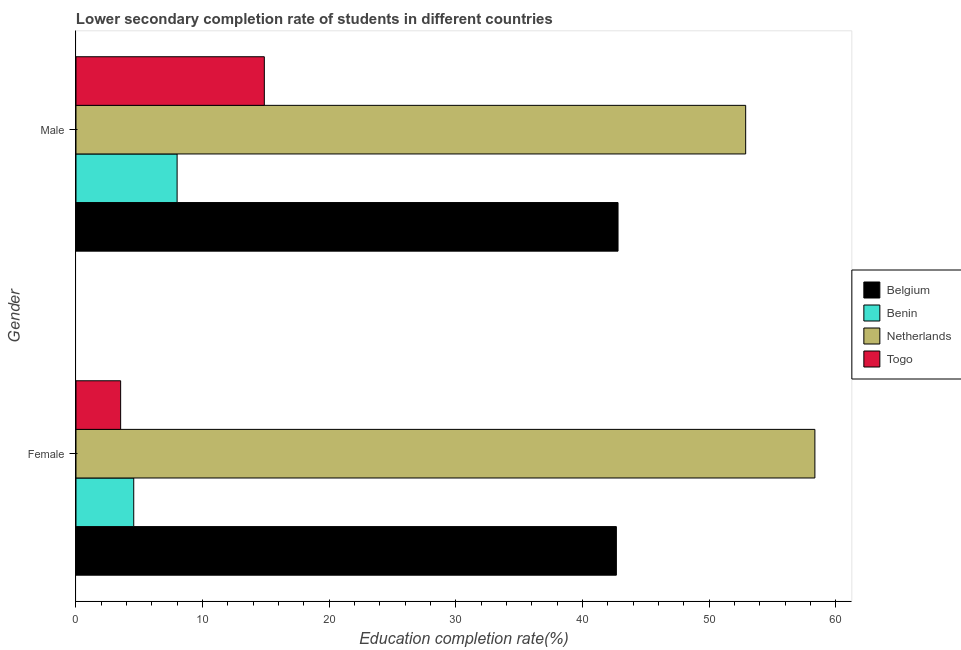How many bars are there on the 2nd tick from the bottom?
Ensure brevity in your answer.  4. What is the education completion rate of female students in Netherlands?
Make the answer very short. 58.34. Across all countries, what is the maximum education completion rate of male students?
Ensure brevity in your answer.  52.88. Across all countries, what is the minimum education completion rate of female students?
Provide a succinct answer. 3.53. In which country was the education completion rate of male students minimum?
Offer a very short reply. Benin. What is the total education completion rate of male students in the graph?
Your answer should be very brief. 118.54. What is the difference between the education completion rate of female students in Togo and that in Netherlands?
Offer a terse response. -54.82. What is the difference between the education completion rate of male students in Togo and the education completion rate of female students in Benin?
Offer a very short reply. 10.31. What is the average education completion rate of female students per country?
Make the answer very short. 27.27. What is the difference between the education completion rate of male students and education completion rate of female students in Togo?
Your response must be concise. 11.35. What is the ratio of the education completion rate of male students in Benin to that in Netherlands?
Your response must be concise. 0.15. Is the education completion rate of female students in Belgium less than that in Benin?
Ensure brevity in your answer.  No. In how many countries, is the education completion rate of male students greater than the average education completion rate of male students taken over all countries?
Offer a very short reply. 2. What does the 4th bar from the bottom in Male represents?
Offer a terse response. Togo. How many bars are there?
Your response must be concise. 8. How many countries are there in the graph?
Provide a short and direct response. 4. What is the difference between two consecutive major ticks on the X-axis?
Ensure brevity in your answer.  10. Does the graph contain grids?
Provide a short and direct response. No. How many legend labels are there?
Offer a very short reply. 4. How are the legend labels stacked?
Make the answer very short. Vertical. What is the title of the graph?
Your answer should be compact. Lower secondary completion rate of students in different countries. What is the label or title of the X-axis?
Your response must be concise. Education completion rate(%). What is the Education completion rate(%) of Belgium in Female?
Make the answer very short. 42.67. What is the Education completion rate(%) of Benin in Female?
Offer a very short reply. 4.56. What is the Education completion rate(%) in Netherlands in Female?
Make the answer very short. 58.34. What is the Education completion rate(%) in Togo in Female?
Your answer should be compact. 3.53. What is the Education completion rate(%) in Belgium in Male?
Give a very brief answer. 42.8. What is the Education completion rate(%) in Benin in Male?
Your answer should be compact. 7.98. What is the Education completion rate(%) of Netherlands in Male?
Your response must be concise. 52.88. What is the Education completion rate(%) in Togo in Male?
Your response must be concise. 14.87. Across all Gender, what is the maximum Education completion rate(%) in Belgium?
Your answer should be compact. 42.8. Across all Gender, what is the maximum Education completion rate(%) in Benin?
Give a very brief answer. 7.98. Across all Gender, what is the maximum Education completion rate(%) in Netherlands?
Give a very brief answer. 58.34. Across all Gender, what is the maximum Education completion rate(%) in Togo?
Make the answer very short. 14.87. Across all Gender, what is the minimum Education completion rate(%) of Belgium?
Offer a terse response. 42.67. Across all Gender, what is the minimum Education completion rate(%) of Benin?
Your answer should be very brief. 4.56. Across all Gender, what is the minimum Education completion rate(%) of Netherlands?
Your answer should be compact. 52.88. Across all Gender, what is the minimum Education completion rate(%) in Togo?
Give a very brief answer. 3.53. What is the total Education completion rate(%) in Belgium in the graph?
Give a very brief answer. 85.47. What is the total Education completion rate(%) in Benin in the graph?
Ensure brevity in your answer.  12.54. What is the total Education completion rate(%) in Netherlands in the graph?
Your answer should be very brief. 111.22. What is the total Education completion rate(%) in Togo in the graph?
Your answer should be compact. 18.4. What is the difference between the Education completion rate(%) in Belgium in Female and that in Male?
Give a very brief answer. -0.13. What is the difference between the Education completion rate(%) of Benin in Female and that in Male?
Make the answer very short. -3.42. What is the difference between the Education completion rate(%) in Netherlands in Female and that in Male?
Keep it short and to the point. 5.47. What is the difference between the Education completion rate(%) in Togo in Female and that in Male?
Your answer should be compact. -11.35. What is the difference between the Education completion rate(%) of Belgium in Female and the Education completion rate(%) of Benin in Male?
Make the answer very short. 34.69. What is the difference between the Education completion rate(%) in Belgium in Female and the Education completion rate(%) in Netherlands in Male?
Ensure brevity in your answer.  -10.21. What is the difference between the Education completion rate(%) in Belgium in Female and the Education completion rate(%) in Togo in Male?
Your response must be concise. 27.8. What is the difference between the Education completion rate(%) of Benin in Female and the Education completion rate(%) of Netherlands in Male?
Give a very brief answer. -48.32. What is the difference between the Education completion rate(%) of Benin in Female and the Education completion rate(%) of Togo in Male?
Ensure brevity in your answer.  -10.31. What is the difference between the Education completion rate(%) of Netherlands in Female and the Education completion rate(%) of Togo in Male?
Your answer should be very brief. 43.47. What is the average Education completion rate(%) in Belgium per Gender?
Your response must be concise. 42.73. What is the average Education completion rate(%) of Benin per Gender?
Ensure brevity in your answer.  6.27. What is the average Education completion rate(%) of Netherlands per Gender?
Offer a terse response. 55.61. What is the average Education completion rate(%) of Togo per Gender?
Provide a short and direct response. 9.2. What is the difference between the Education completion rate(%) of Belgium and Education completion rate(%) of Benin in Female?
Your answer should be very brief. 38.11. What is the difference between the Education completion rate(%) in Belgium and Education completion rate(%) in Netherlands in Female?
Your response must be concise. -15.68. What is the difference between the Education completion rate(%) in Belgium and Education completion rate(%) in Togo in Female?
Provide a succinct answer. 39.14. What is the difference between the Education completion rate(%) of Benin and Education completion rate(%) of Netherlands in Female?
Give a very brief answer. -53.78. What is the difference between the Education completion rate(%) of Benin and Education completion rate(%) of Togo in Female?
Give a very brief answer. 1.03. What is the difference between the Education completion rate(%) of Netherlands and Education completion rate(%) of Togo in Female?
Your answer should be very brief. 54.82. What is the difference between the Education completion rate(%) in Belgium and Education completion rate(%) in Benin in Male?
Offer a very short reply. 34.82. What is the difference between the Education completion rate(%) in Belgium and Education completion rate(%) in Netherlands in Male?
Ensure brevity in your answer.  -10.08. What is the difference between the Education completion rate(%) of Belgium and Education completion rate(%) of Togo in Male?
Provide a succinct answer. 27.93. What is the difference between the Education completion rate(%) in Benin and Education completion rate(%) in Netherlands in Male?
Your answer should be very brief. -44.9. What is the difference between the Education completion rate(%) of Benin and Education completion rate(%) of Togo in Male?
Your response must be concise. -6.89. What is the difference between the Education completion rate(%) of Netherlands and Education completion rate(%) of Togo in Male?
Your answer should be very brief. 38.01. What is the ratio of the Education completion rate(%) in Benin in Female to that in Male?
Your answer should be very brief. 0.57. What is the ratio of the Education completion rate(%) in Netherlands in Female to that in Male?
Provide a succinct answer. 1.1. What is the ratio of the Education completion rate(%) in Togo in Female to that in Male?
Your response must be concise. 0.24. What is the difference between the highest and the second highest Education completion rate(%) in Belgium?
Provide a succinct answer. 0.13. What is the difference between the highest and the second highest Education completion rate(%) of Benin?
Offer a terse response. 3.42. What is the difference between the highest and the second highest Education completion rate(%) of Netherlands?
Your answer should be very brief. 5.47. What is the difference between the highest and the second highest Education completion rate(%) in Togo?
Offer a very short reply. 11.35. What is the difference between the highest and the lowest Education completion rate(%) in Belgium?
Ensure brevity in your answer.  0.13. What is the difference between the highest and the lowest Education completion rate(%) of Benin?
Your response must be concise. 3.42. What is the difference between the highest and the lowest Education completion rate(%) of Netherlands?
Offer a terse response. 5.47. What is the difference between the highest and the lowest Education completion rate(%) in Togo?
Provide a succinct answer. 11.35. 